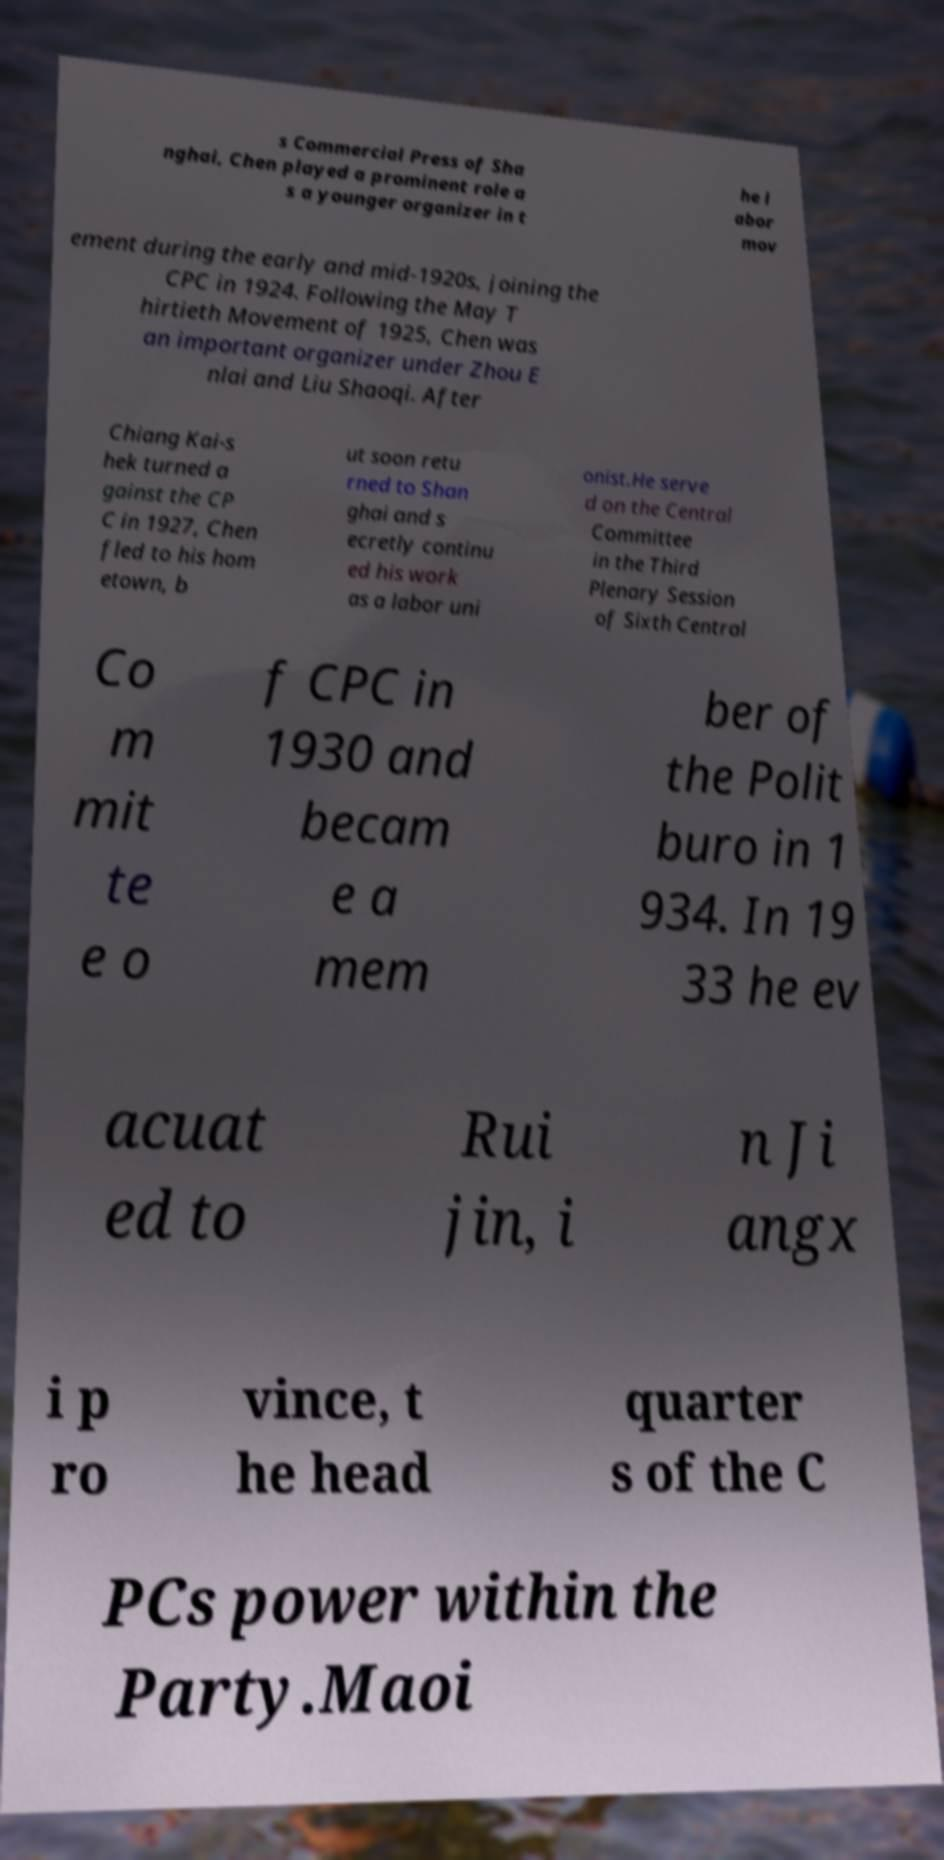What messages or text are displayed in this image? I need them in a readable, typed format. s Commercial Press of Sha nghai, Chen played a prominent role a s a younger organizer in t he l abor mov ement during the early and mid-1920s, joining the CPC in 1924. Following the May T hirtieth Movement of 1925, Chen was an important organizer under Zhou E nlai and Liu Shaoqi. After Chiang Kai-s hek turned a gainst the CP C in 1927, Chen fled to his hom etown, b ut soon retu rned to Shan ghai and s ecretly continu ed his work as a labor uni onist.He serve d on the Central Committee in the Third Plenary Session of Sixth Central Co m mit te e o f CPC in 1930 and becam e a mem ber of the Polit buro in 1 934. In 19 33 he ev acuat ed to Rui jin, i n Ji angx i p ro vince, t he head quarter s of the C PCs power within the Party.Maoi 